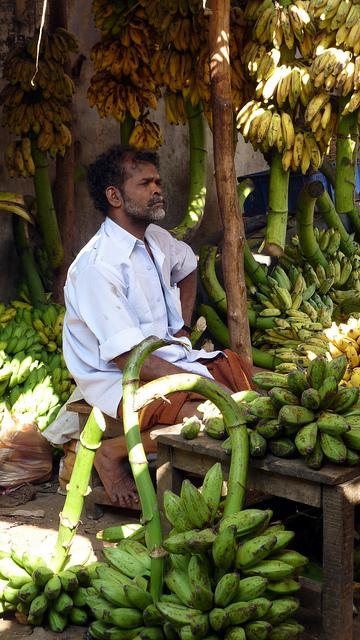Are bananas high in potassium?
Be succinct. Yes. Are there many or few bananas?
Quick response, please. Many. What fruit is the man selling?
Be succinct. Bananas. 